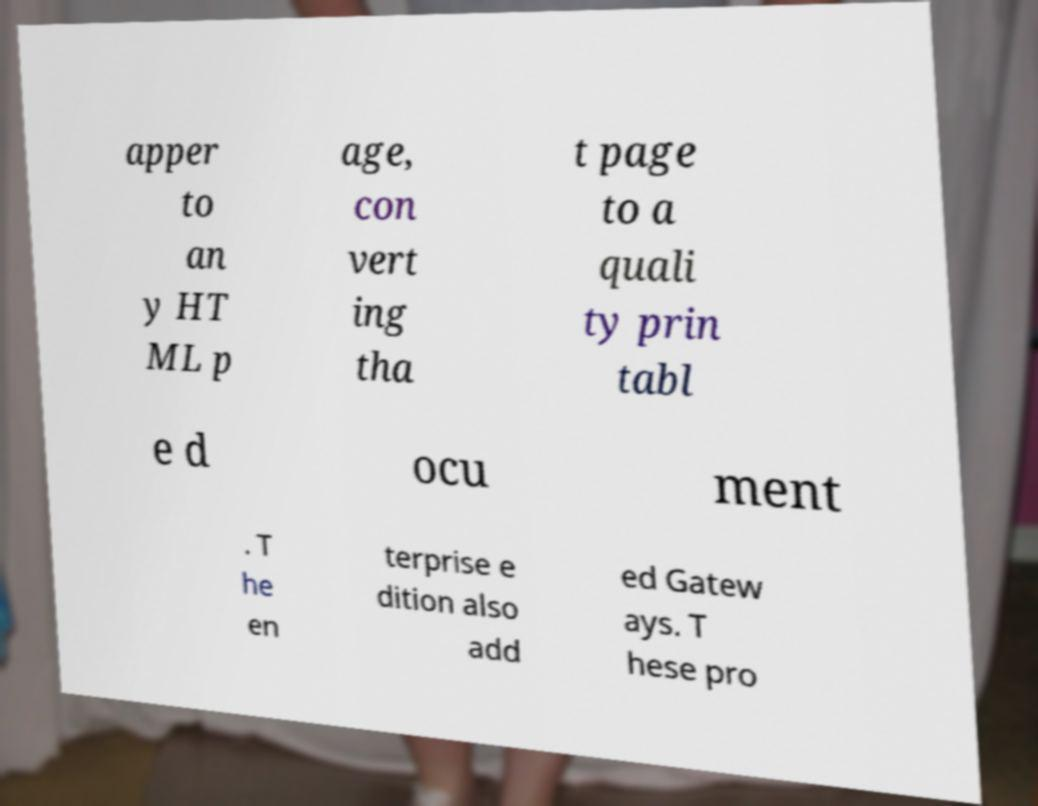Please read and relay the text visible in this image. What does it say? apper to an y HT ML p age, con vert ing tha t page to a quali ty prin tabl e d ocu ment . T he en terprise e dition also add ed Gatew ays. T hese pro 